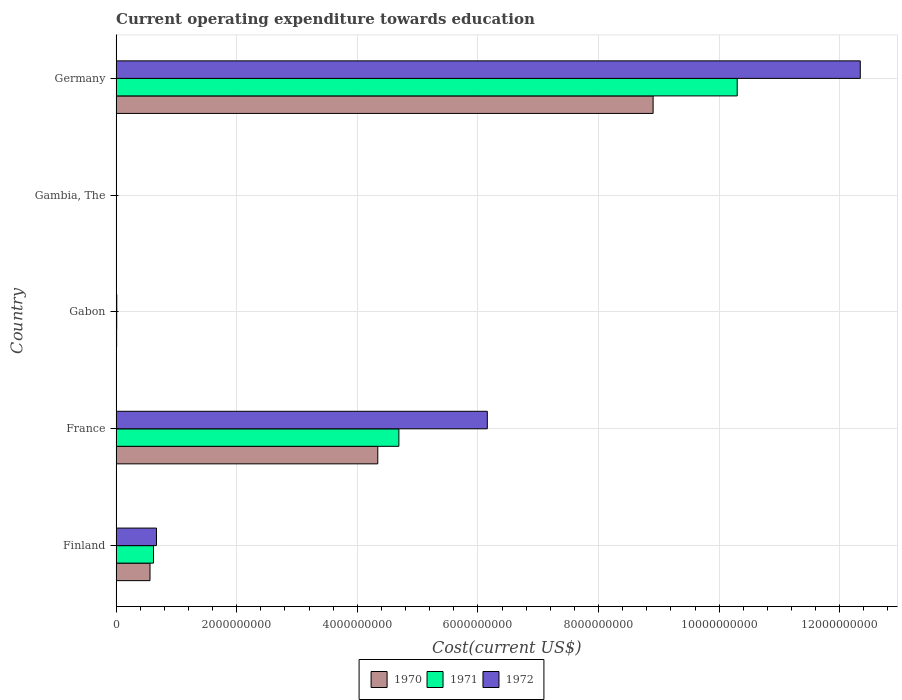How many groups of bars are there?
Provide a short and direct response. 5. Are the number of bars on each tick of the Y-axis equal?
Your answer should be compact. Yes. In how many cases, is the number of bars for a given country not equal to the number of legend labels?
Your response must be concise. 0. What is the expenditure towards education in 1970 in Gabon?
Keep it short and to the point. 8.29e+06. Across all countries, what is the maximum expenditure towards education in 1971?
Offer a very short reply. 1.03e+1. Across all countries, what is the minimum expenditure towards education in 1971?
Your response must be concise. 1.20e+06. In which country was the expenditure towards education in 1970 minimum?
Keep it short and to the point. Gambia, The. What is the total expenditure towards education in 1972 in the graph?
Your response must be concise. 1.92e+1. What is the difference between the expenditure towards education in 1972 in Gabon and that in Germany?
Your answer should be very brief. -1.23e+1. What is the difference between the expenditure towards education in 1972 in Germany and the expenditure towards education in 1970 in France?
Provide a short and direct response. 8.00e+09. What is the average expenditure towards education in 1970 per country?
Offer a terse response. 2.76e+09. What is the difference between the expenditure towards education in 1972 and expenditure towards education in 1970 in Finland?
Offer a terse response. 1.07e+08. In how many countries, is the expenditure towards education in 1970 greater than 11200000000 US$?
Your answer should be very brief. 0. What is the ratio of the expenditure towards education in 1970 in Finland to that in France?
Your answer should be very brief. 0.13. Is the difference between the expenditure towards education in 1972 in Finland and France greater than the difference between the expenditure towards education in 1970 in Finland and France?
Your answer should be compact. No. What is the difference between the highest and the second highest expenditure towards education in 1971?
Make the answer very short. 5.61e+09. What is the difference between the highest and the lowest expenditure towards education in 1972?
Offer a very short reply. 1.23e+1. Is the sum of the expenditure towards education in 1971 in Finland and Gabon greater than the maximum expenditure towards education in 1970 across all countries?
Your answer should be compact. No. How many bars are there?
Offer a terse response. 15. Does the graph contain grids?
Ensure brevity in your answer.  Yes. Where does the legend appear in the graph?
Provide a succinct answer. Bottom center. How many legend labels are there?
Offer a very short reply. 3. How are the legend labels stacked?
Give a very brief answer. Horizontal. What is the title of the graph?
Offer a very short reply. Current operating expenditure towards education. Does "1997" appear as one of the legend labels in the graph?
Keep it short and to the point. No. What is the label or title of the X-axis?
Provide a succinct answer. Cost(current US$). What is the Cost(current US$) of 1970 in Finland?
Keep it short and to the point. 5.62e+08. What is the Cost(current US$) of 1971 in Finland?
Your answer should be very brief. 6.20e+08. What is the Cost(current US$) of 1972 in Finland?
Offer a very short reply. 6.69e+08. What is the Cost(current US$) of 1970 in France?
Offer a very short reply. 4.34e+09. What is the Cost(current US$) of 1971 in France?
Your answer should be compact. 4.69e+09. What is the Cost(current US$) of 1972 in France?
Your answer should be compact. 6.16e+09. What is the Cost(current US$) of 1970 in Gabon?
Make the answer very short. 8.29e+06. What is the Cost(current US$) in 1971 in Gabon?
Provide a short and direct response. 9.66e+06. What is the Cost(current US$) of 1972 in Gabon?
Make the answer very short. 1.09e+07. What is the Cost(current US$) in 1970 in Gambia, The?
Ensure brevity in your answer.  1.15e+06. What is the Cost(current US$) of 1971 in Gambia, The?
Offer a terse response. 1.20e+06. What is the Cost(current US$) of 1972 in Gambia, The?
Give a very brief answer. 1.44e+06. What is the Cost(current US$) of 1970 in Germany?
Ensure brevity in your answer.  8.90e+09. What is the Cost(current US$) in 1971 in Germany?
Your response must be concise. 1.03e+1. What is the Cost(current US$) in 1972 in Germany?
Ensure brevity in your answer.  1.23e+1. Across all countries, what is the maximum Cost(current US$) in 1970?
Make the answer very short. 8.90e+09. Across all countries, what is the maximum Cost(current US$) of 1971?
Make the answer very short. 1.03e+1. Across all countries, what is the maximum Cost(current US$) of 1972?
Provide a succinct answer. 1.23e+1. Across all countries, what is the minimum Cost(current US$) in 1970?
Ensure brevity in your answer.  1.15e+06. Across all countries, what is the minimum Cost(current US$) in 1971?
Offer a very short reply. 1.20e+06. Across all countries, what is the minimum Cost(current US$) in 1972?
Give a very brief answer. 1.44e+06. What is the total Cost(current US$) of 1970 in the graph?
Your answer should be very brief. 1.38e+1. What is the total Cost(current US$) in 1971 in the graph?
Keep it short and to the point. 1.56e+1. What is the total Cost(current US$) of 1972 in the graph?
Ensure brevity in your answer.  1.92e+1. What is the difference between the Cost(current US$) of 1970 in Finland and that in France?
Your response must be concise. -3.78e+09. What is the difference between the Cost(current US$) in 1971 in Finland and that in France?
Offer a very short reply. -4.07e+09. What is the difference between the Cost(current US$) of 1972 in Finland and that in France?
Your response must be concise. -5.49e+09. What is the difference between the Cost(current US$) in 1970 in Finland and that in Gabon?
Your answer should be compact. 5.54e+08. What is the difference between the Cost(current US$) in 1971 in Finland and that in Gabon?
Offer a terse response. 6.10e+08. What is the difference between the Cost(current US$) of 1972 in Finland and that in Gabon?
Offer a very short reply. 6.58e+08. What is the difference between the Cost(current US$) of 1970 in Finland and that in Gambia, The?
Make the answer very short. 5.61e+08. What is the difference between the Cost(current US$) of 1971 in Finland and that in Gambia, The?
Keep it short and to the point. 6.18e+08. What is the difference between the Cost(current US$) of 1972 in Finland and that in Gambia, The?
Offer a terse response. 6.67e+08. What is the difference between the Cost(current US$) in 1970 in Finland and that in Germany?
Your answer should be compact. -8.34e+09. What is the difference between the Cost(current US$) of 1971 in Finland and that in Germany?
Your answer should be very brief. -9.68e+09. What is the difference between the Cost(current US$) of 1972 in Finland and that in Germany?
Keep it short and to the point. -1.17e+1. What is the difference between the Cost(current US$) of 1970 in France and that in Gabon?
Provide a short and direct response. 4.33e+09. What is the difference between the Cost(current US$) in 1971 in France and that in Gabon?
Make the answer very short. 4.68e+09. What is the difference between the Cost(current US$) of 1972 in France and that in Gabon?
Your answer should be very brief. 6.14e+09. What is the difference between the Cost(current US$) in 1970 in France and that in Gambia, The?
Give a very brief answer. 4.34e+09. What is the difference between the Cost(current US$) of 1971 in France and that in Gambia, The?
Offer a terse response. 4.69e+09. What is the difference between the Cost(current US$) of 1972 in France and that in Gambia, The?
Your response must be concise. 6.15e+09. What is the difference between the Cost(current US$) of 1970 in France and that in Germany?
Your answer should be compact. -4.57e+09. What is the difference between the Cost(current US$) of 1971 in France and that in Germany?
Your answer should be compact. -5.61e+09. What is the difference between the Cost(current US$) in 1972 in France and that in Germany?
Your response must be concise. -6.19e+09. What is the difference between the Cost(current US$) of 1970 in Gabon and that in Gambia, The?
Ensure brevity in your answer.  7.14e+06. What is the difference between the Cost(current US$) in 1971 in Gabon and that in Gambia, The?
Ensure brevity in your answer.  8.46e+06. What is the difference between the Cost(current US$) of 1972 in Gabon and that in Gambia, The?
Keep it short and to the point. 9.41e+06. What is the difference between the Cost(current US$) in 1970 in Gabon and that in Germany?
Give a very brief answer. -8.90e+09. What is the difference between the Cost(current US$) of 1971 in Gabon and that in Germany?
Your response must be concise. -1.03e+1. What is the difference between the Cost(current US$) in 1972 in Gabon and that in Germany?
Your response must be concise. -1.23e+1. What is the difference between the Cost(current US$) in 1970 in Gambia, The and that in Germany?
Provide a succinct answer. -8.90e+09. What is the difference between the Cost(current US$) of 1971 in Gambia, The and that in Germany?
Provide a short and direct response. -1.03e+1. What is the difference between the Cost(current US$) of 1972 in Gambia, The and that in Germany?
Offer a very short reply. -1.23e+1. What is the difference between the Cost(current US$) of 1970 in Finland and the Cost(current US$) of 1971 in France?
Keep it short and to the point. -4.13e+09. What is the difference between the Cost(current US$) in 1970 in Finland and the Cost(current US$) in 1972 in France?
Provide a succinct answer. -5.59e+09. What is the difference between the Cost(current US$) in 1971 in Finland and the Cost(current US$) in 1972 in France?
Your answer should be compact. -5.54e+09. What is the difference between the Cost(current US$) in 1970 in Finland and the Cost(current US$) in 1971 in Gabon?
Your response must be concise. 5.52e+08. What is the difference between the Cost(current US$) in 1970 in Finland and the Cost(current US$) in 1972 in Gabon?
Provide a short and direct response. 5.51e+08. What is the difference between the Cost(current US$) of 1971 in Finland and the Cost(current US$) of 1972 in Gabon?
Ensure brevity in your answer.  6.09e+08. What is the difference between the Cost(current US$) of 1970 in Finland and the Cost(current US$) of 1971 in Gambia, The?
Your response must be concise. 5.61e+08. What is the difference between the Cost(current US$) of 1970 in Finland and the Cost(current US$) of 1972 in Gambia, The?
Your answer should be compact. 5.61e+08. What is the difference between the Cost(current US$) of 1971 in Finland and the Cost(current US$) of 1972 in Gambia, The?
Your answer should be compact. 6.18e+08. What is the difference between the Cost(current US$) in 1970 in Finland and the Cost(current US$) in 1971 in Germany?
Give a very brief answer. -9.74e+09. What is the difference between the Cost(current US$) in 1970 in Finland and the Cost(current US$) in 1972 in Germany?
Provide a short and direct response. -1.18e+1. What is the difference between the Cost(current US$) of 1971 in Finland and the Cost(current US$) of 1972 in Germany?
Provide a short and direct response. -1.17e+1. What is the difference between the Cost(current US$) in 1970 in France and the Cost(current US$) in 1971 in Gabon?
Your answer should be very brief. 4.33e+09. What is the difference between the Cost(current US$) of 1970 in France and the Cost(current US$) of 1972 in Gabon?
Provide a short and direct response. 4.33e+09. What is the difference between the Cost(current US$) of 1971 in France and the Cost(current US$) of 1972 in Gabon?
Offer a very short reply. 4.68e+09. What is the difference between the Cost(current US$) of 1970 in France and the Cost(current US$) of 1971 in Gambia, The?
Offer a terse response. 4.34e+09. What is the difference between the Cost(current US$) of 1970 in France and the Cost(current US$) of 1972 in Gambia, The?
Ensure brevity in your answer.  4.34e+09. What is the difference between the Cost(current US$) of 1971 in France and the Cost(current US$) of 1972 in Gambia, The?
Your answer should be compact. 4.69e+09. What is the difference between the Cost(current US$) in 1970 in France and the Cost(current US$) in 1971 in Germany?
Provide a short and direct response. -5.96e+09. What is the difference between the Cost(current US$) of 1970 in France and the Cost(current US$) of 1972 in Germany?
Offer a terse response. -8.00e+09. What is the difference between the Cost(current US$) of 1971 in France and the Cost(current US$) of 1972 in Germany?
Provide a short and direct response. -7.65e+09. What is the difference between the Cost(current US$) in 1970 in Gabon and the Cost(current US$) in 1971 in Gambia, The?
Give a very brief answer. 7.10e+06. What is the difference between the Cost(current US$) in 1970 in Gabon and the Cost(current US$) in 1972 in Gambia, The?
Ensure brevity in your answer.  6.85e+06. What is the difference between the Cost(current US$) in 1971 in Gabon and the Cost(current US$) in 1972 in Gambia, The?
Provide a succinct answer. 8.22e+06. What is the difference between the Cost(current US$) in 1970 in Gabon and the Cost(current US$) in 1971 in Germany?
Ensure brevity in your answer.  -1.03e+1. What is the difference between the Cost(current US$) of 1970 in Gabon and the Cost(current US$) of 1972 in Germany?
Make the answer very short. -1.23e+1. What is the difference between the Cost(current US$) of 1971 in Gabon and the Cost(current US$) of 1972 in Germany?
Ensure brevity in your answer.  -1.23e+1. What is the difference between the Cost(current US$) of 1970 in Gambia, The and the Cost(current US$) of 1971 in Germany?
Ensure brevity in your answer.  -1.03e+1. What is the difference between the Cost(current US$) of 1970 in Gambia, The and the Cost(current US$) of 1972 in Germany?
Keep it short and to the point. -1.23e+1. What is the difference between the Cost(current US$) of 1971 in Gambia, The and the Cost(current US$) of 1972 in Germany?
Offer a terse response. -1.23e+1. What is the average Cost(current US$) in 1970 per country?
Offer a very short reply. 2.76e+09. What is the average Cost(current US$) of 1971 per country?
Provide a succinct answer. 3.12e+09. What is the average Cost(current US$) in 1972 per country?
Offer a very short reply. 3.84e+09. What is the difference between the Cost(current US$) in 1970 and Cost(current US$) in 1971 in Finland?
Your response must be concise. -5.76e+07. What is the difference between the Cost(current US$) in 1970 and Cost(current US$) in 1972 in Finland?
Keep it short and to the point. -1.07e+08. What is the difference between the Cost(current US$) of 1971 and Cost(current US$) of 1972 in Finland?
Your answer should be very brief. -4.93e+07. What is the difference between the Cost(current US$) of 1970 and Cost(current US$) of 1971 in France?
Offer a very short reply. -3.50e+08. What is the difference between the Cost(current US$) in 1970 and Cost(current US$) in 1972 in France?
Provide a short and direct response. -1.82e+09. What is the difference between the Cost(current US$) of 1971 and Cost(current US$) of 1972 in France?
Make the answer very short. -1.47e+09. What is the difference between the Cost(current US$) in 1970 and Cost(current US$) in 1971 in Gabon?
Make the answer very short. -1.37e+06. What is the difference between the Cost(current US$) of 1970 and Cost(current US$) of 1972 in Gabon?
Offer a terse response. -2.56e+06. What is the difference between the Cost(current US$) of 1971 and Cost(current US$) of 1972 in Gabon?
Make the answer very short. -1.19e+06. What is the difference between the Cost(current US$) in 1970 and Cost(current US$) in 1971 in Gambia, The?
Give a very brief answer. -4.75e+04. What is the difference between the Cost(current US$) in 1970 and Cost(current US$) in 1972 in Gambia, The?
Provide a short and direct response. -2.88e+05. What is the difference between the Cost(current US$) of 1971 and Cost(current US$) of 1972 in Gambia, The?
Offer a terse response. -2.40e+05. What is the difference between the Cost(current US$) of 1970 and Cost(current US$) of 1971 in Germany?
Your response must be concise. -1.39e+09. What is the difference between the Cost(current US$) in 1970 and Cost(current US$) in 1972 in Germany?
Your answer should be compact. -3.44e+09. What is the difference between the Cost(current US$) of 1971 and Cost(current US$) of 1972 in Germany?
Provide a succinct answer. -2.04e+09. What is the ratio of the Cost(current US$) of 1970 in Finland to that in France?
Keep it short and to the point. 0.13. What is the ratio of the Cost(current US$) of 1971 in Finland to that in France?
Your answer should be compact. 0.13. What is the ratio of the Cost(current US$) in 1972 in Finland to that in France?
Make the answer very short. 0.11. What is the ratio of the Cost(current US$) of 1970 in Finland to that in Gabon?
Give a very brief answer. 67.76. What is the ratio of the Cost(current US$) of 1971 in Finland to that in Gabon?
Your response must be concise. 64.15. What is the ratio of the Cost(current US$) in 1972 in Finland to that in Gabon?
Give a very brief answer. 61.64. What is the ratio of the Cost(current US$) in 1970 in Finland to that in Gambia, The?
Provide a short and direct response. 488.46. What is the ratio of the Cost(current US$) of 1971 in Finland to that in Gambia, The?
Ensure brevity in your answer.  517.15. What is the ratio of the Cost(current US$) of 1972 in Finland to that in Gambia, The?
Offer a terse response. 464.99. What is the ratio of the Cost(current US$) of 1970 in Finland to that in Germany?
Ensure brevity in your answer.  0.06. What is the ratio of the Cost(current US$) of 1971 in Finland to that in Germany?
Provide a short and direct response. 0.06. What is the ratio of the Cost(current US$) of 1972 in Finland to that in Germany?
Your response must be concise. 0.05. What is the ratio of the Cost(current US$) in 1970 in France to that in Gabon?
Give a very brief answer. 523.2. What is the ratio of the Cost(current US$) in 1971 in France to that in Gabon?
Provide a succinct answer. 485.47. What is the ratio of the Cost(current US$) in 1972 in France to that in Gabon?
Give a very brief answer. 567.19. What is the ratio of the Cost(current US$) of 1970 in France to that in Gambia, The?
Provide a succinct answer. 3771.39. What is the ratio of the Cost(current US$) in 1971 in France to that in Gambia, The?
Offer a terse response. 3913.76. What is the ratio of the Cost(current US$) in 1972 in France to that in Gambia, The?
Your answer should be compact. 4278.91. What is the ratio of the Cost(current US$) in 1970 in France to that in Germany?
Your answer should be compact. 0.49. What is the ratio of the Cost(current US$) of 1971 in France to that in Germany?
Your answer should be very brief. 0.46. What is the ratio of the Cost(current US$) in 1972 in France to that in Germany?
Keep it short and to the point. 0.5. What is the ratio of the Cost(current US$) in 1970 in Gabon to that in Gambia, The?
Provide a succinct answer. 7.21. What is the ratio of the Cost(current US$) in 1971 in Gabon to that in Gambia, The?
Keep it short and to the point. 8.06. What is the ratio of the Cost(current US$) in 1972 in Gabon to that in Gambia, The?
Your answer should be very brief. 7.54. What is the ratio of the Cost(current US$) in 1970 in Gabon to that in Germany?
Your answer should be compact. 0. What is the ratio of the Cost(current US$) in 1971 in Gabon to that in Germany?
Your answer should be compact. 0. What is the ratio of the Cost(current US$) in 1972 in Gabon to that in Germany?
Offer a very short reply. 0. What is the ratio of the Cost(current US$) in 1971 in Gambia, The to that in Germany?
Give a very brief answer. 0. What is the difference between the highest and the second highest Cost(current US$) in 1970?
Offer a very short reply. 4.57e+09. What is the difference between the highest and the second highest Cost(current US$) of 1971?
Your answer should be very brief. 5.61e+09. What is the difference between the highest and the second highest Cost(current US$) of 1972?
Ensure brevity in your answer.  6.19e+09. What is the difference between the highest and the lowest Cost(current US$) in 1970?
Provide a short and direct response. 8.90e+09. What is the difference between the highest and the lowest Cost(current US$) of 1971?
Provide a short and direct response. 1.03e+1. What is the difference between the highest and the lowest Cost(current US$) of 1972?
Ensure brevity in your answer.  1.23e+1. 